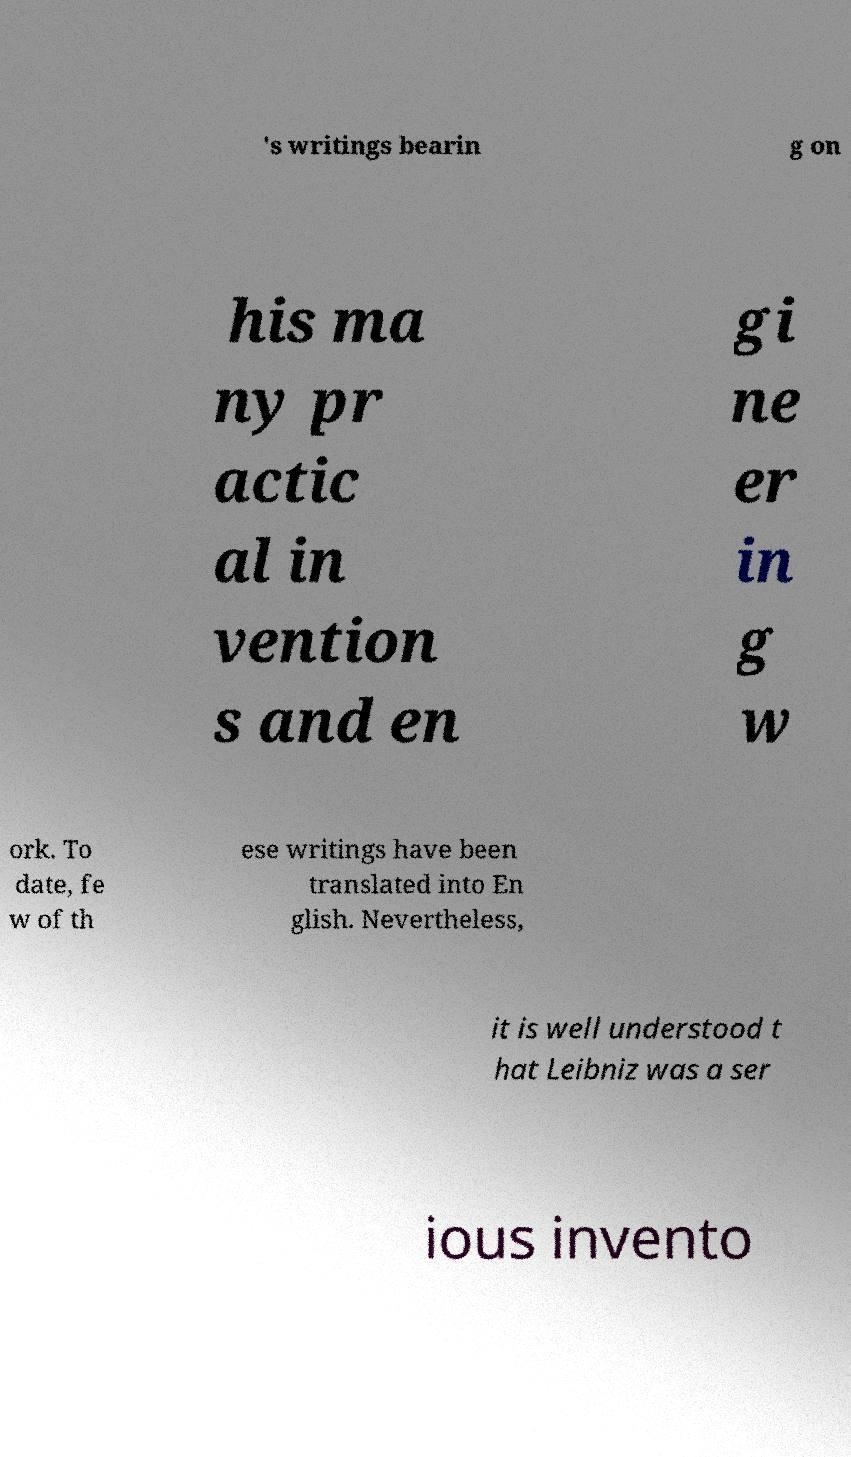Can you accurately transcribe the text from the provided image for me? 's writings bearin g on his ma ny pr actic al in vention s and en gi ne er in g w ork. To date, fe w of th ese writings have been translated into En glish. Nevertheless, it is well understood t hat Leibniz was a ser ious invento 